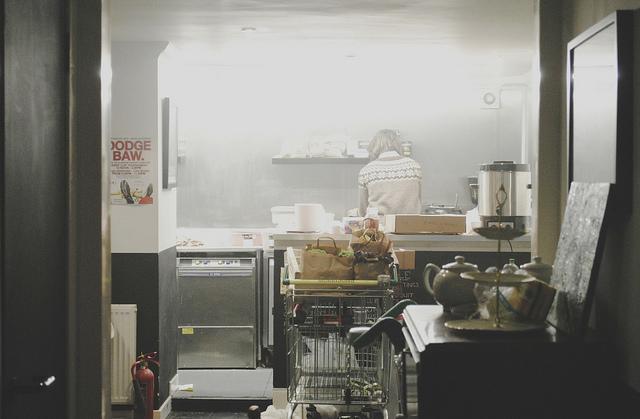How many motorcycles can be seen?
Give a very brief answer. 0. 